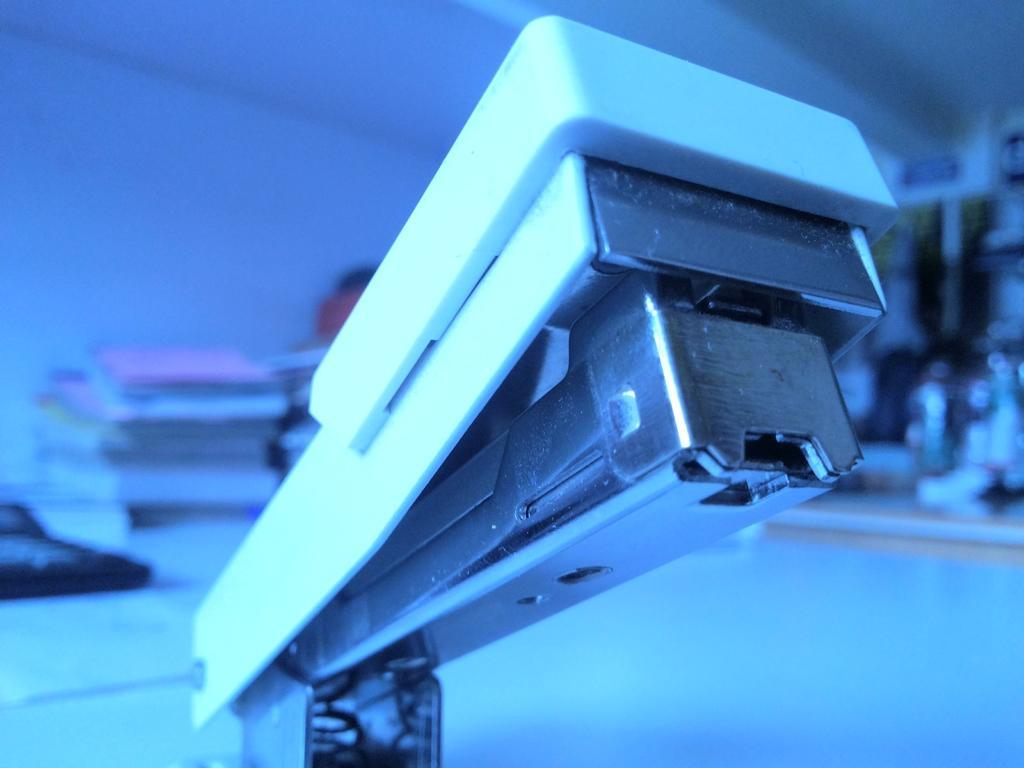Describe this image in one or two sentences. In this image I can see a stapler and I can see this image is little bit blurry from background. I can also see this image is little bit in blue colour. 